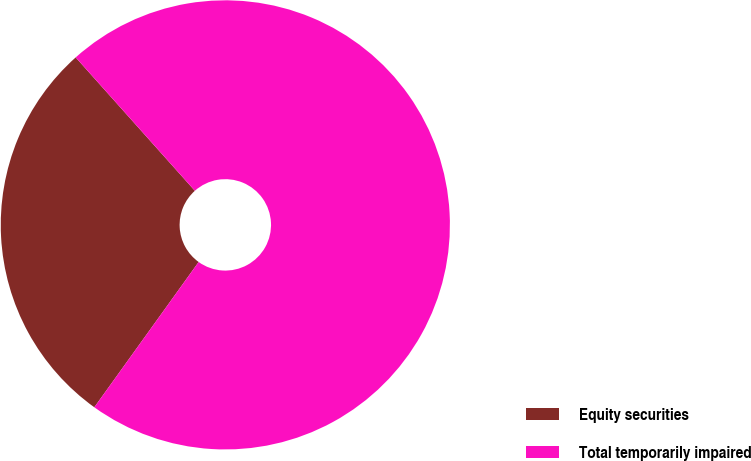<chart> <loc_0><loc_0><loc_500><loc_500><pie_chart><fcel>Equity securities<fcel>Total temporarily impaired<nl><fcel>28.48%<fcel>71.52%<nl></chart> 